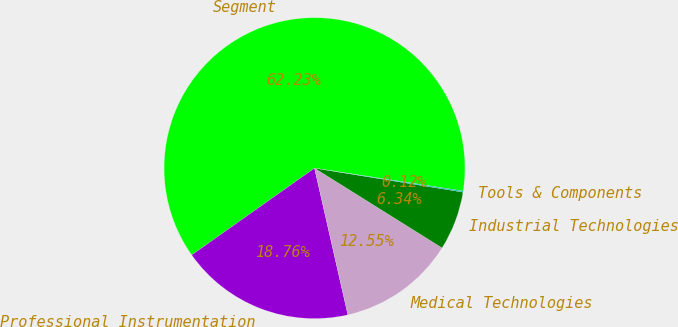<chart> <loc_0><loc_0><loc_500><loc_500><pie_chart><fcel>Segment<fcel>Professional Instrumentation<fcel>Medical Technologies<fcel>Industrial Technologies<fcel>Tools & Components<nl><fcel>62.24%<fcel>18.76%<fcel>12.55%<fcel>6.34%<fcel>0.12%<nl></chart> 